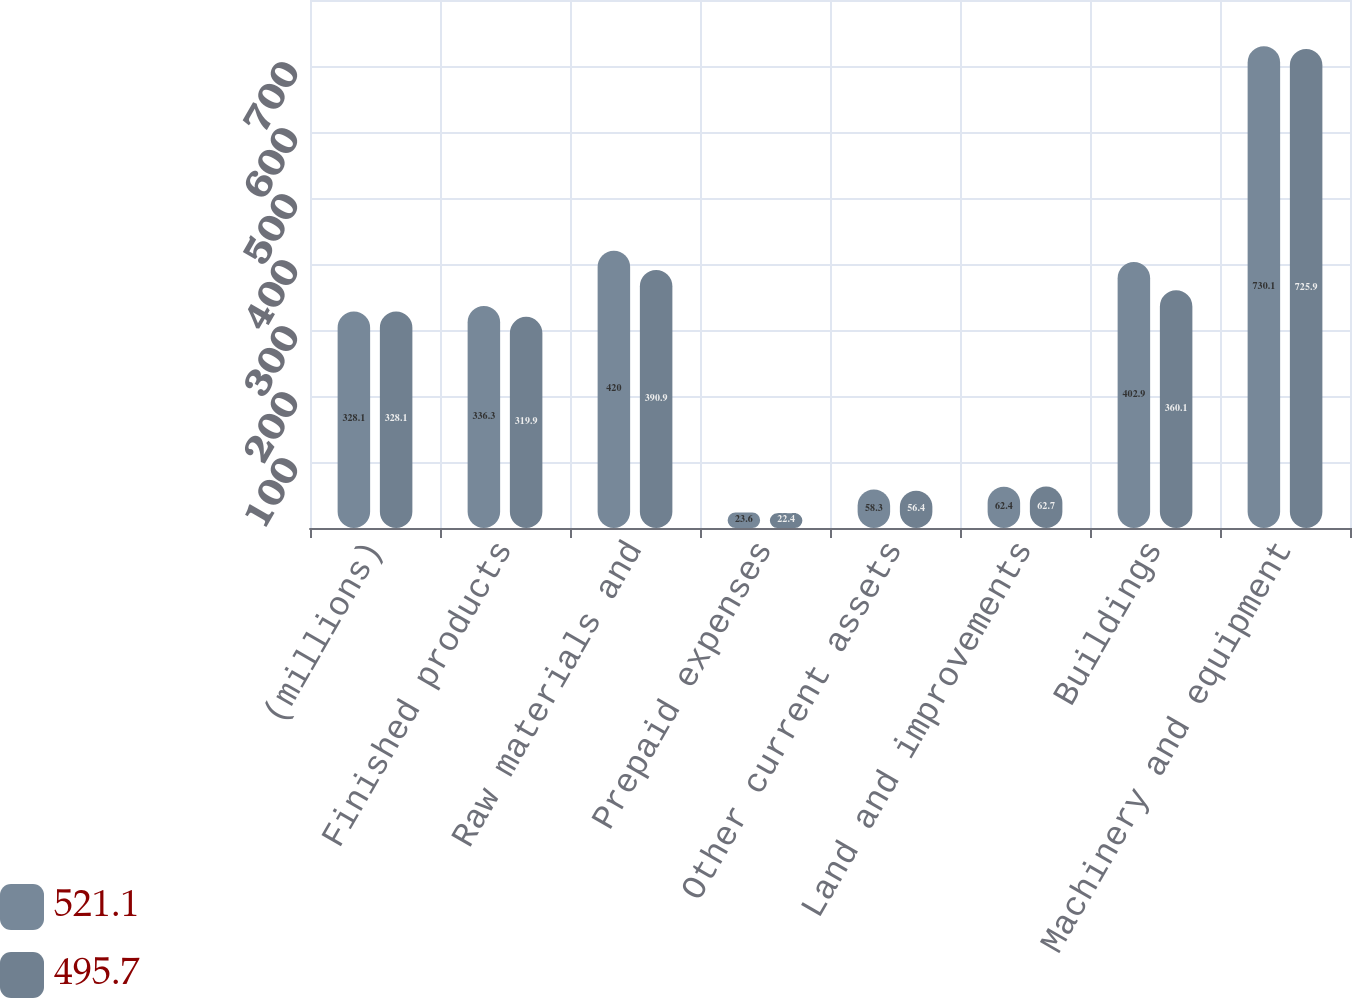Convert chart to OTSL. <chart><loc_0><loc_0><loc_500><loc_500><stacked_bar_chart><ecel><fcel>(millions)<fcel>Finished products<fcel>Raw materials and<fcel>Prepaid expenses<fcel>Other current assets<fcel>Land and improvements<fcel>Buildings<fcel>Machinery and equipment<nl><fcel>521.1<fcel>328.1<fcel>336.3<fcel>420<fcel>23.6<fcel>58.3<fcel>62.4<fcel>402.9<fcel>730.1<nl><fcel>495.7<fcel>328.1<fcel>319.9<fcel>390.9<fcel>22.4<fcel>56.4<fcel>62.7<fcel>360.1<fcel>725.9<nl></chart> 